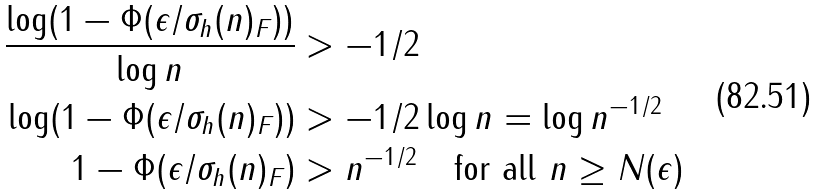Convert formula to latex. <formula><loc_0><loc_0><loc_500><loc_500>\frac { \log ( 1 - \Phi ( \epsilon / \| \sigma _ { h } ( n ) \| _ { F } ) ) } { \log n } & > - 1 / 2 \\ \log ( 1 - \Phi ( \epsilon / \| \sigma _ { h } ( n ) \| _ { F } ) ) & > - 1 / 2 \log n = \log n ^ { - 1 / 2 } \\ 1 - \Phi ( \epsilon / \| \sigma _ { h } ( n ) \| _ { F } ) & > n ^ { - 1 / 2 } \quad \text {for all $n\geq N(\epsilon)$}</formula> 